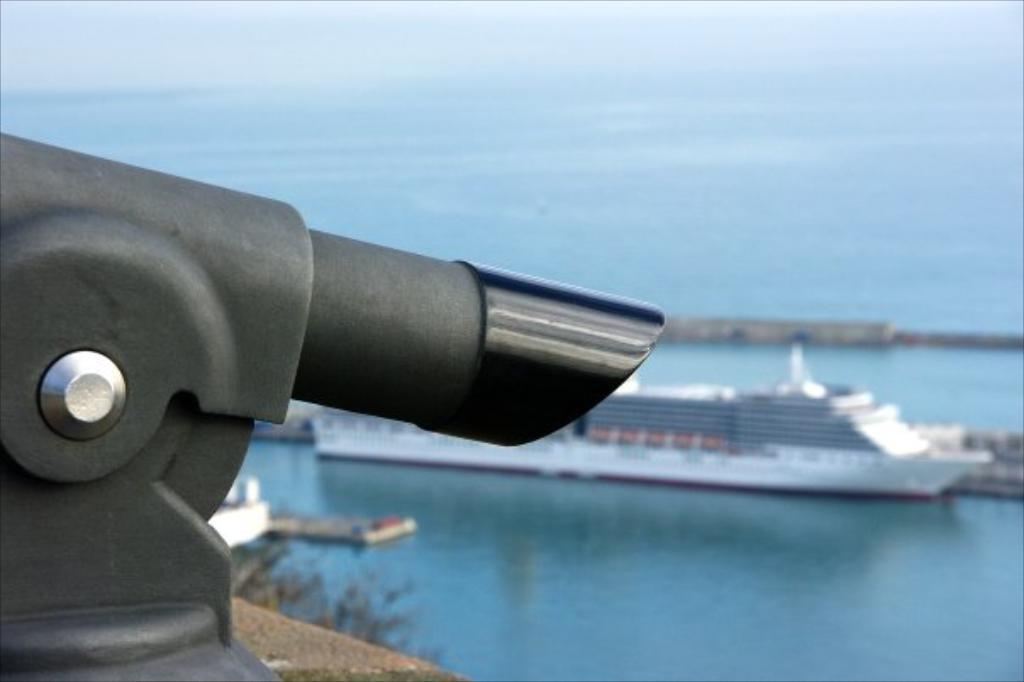What is the main subject in the foreground of the image? There is an object in the foreground of the image. What can be seen in the background of the image? There is a ship, a river, and trees in the background of the image. What is visible at the top of the image? The sky is visible at the top of the image. What type of dirt can be seen on the country road in the image? There is no country road or dirt present in the image. What is the name of the country where the image was taken? The provided facts do not mention the country where the image was taken, so it cannot be determined. 